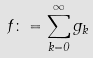<formula> <loc_0><loc_0><loc_500><loc_500>f \colon = \sum _ { k = 0 } ^ { \infty } g _ { k }</formula> 